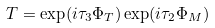<formula> <loc_0><loc_0><loc_500><loc_500>T = \exp ( i \tau _ { 3 } \Phi _ { T } ) \exp ( i \tau _ { 2 } \Phi _ { M } )</formula> 